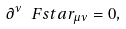<formula> <loc_0><loc_0><loc_500><loc_500>\partial ^ { \nu } \, \ F s t a r _ { \mu \nu } = 0 ,</formula> 